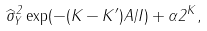Convert formula to latex. <formula><loc_0><loc_0><loc_500><loc_500>\widehat { \sigma } ^ { 2 } _ { Y } \exp ( - ( K - K ^ { \prime } ) A / I ) + \alpha 2 ^ { K } ,</formula> 